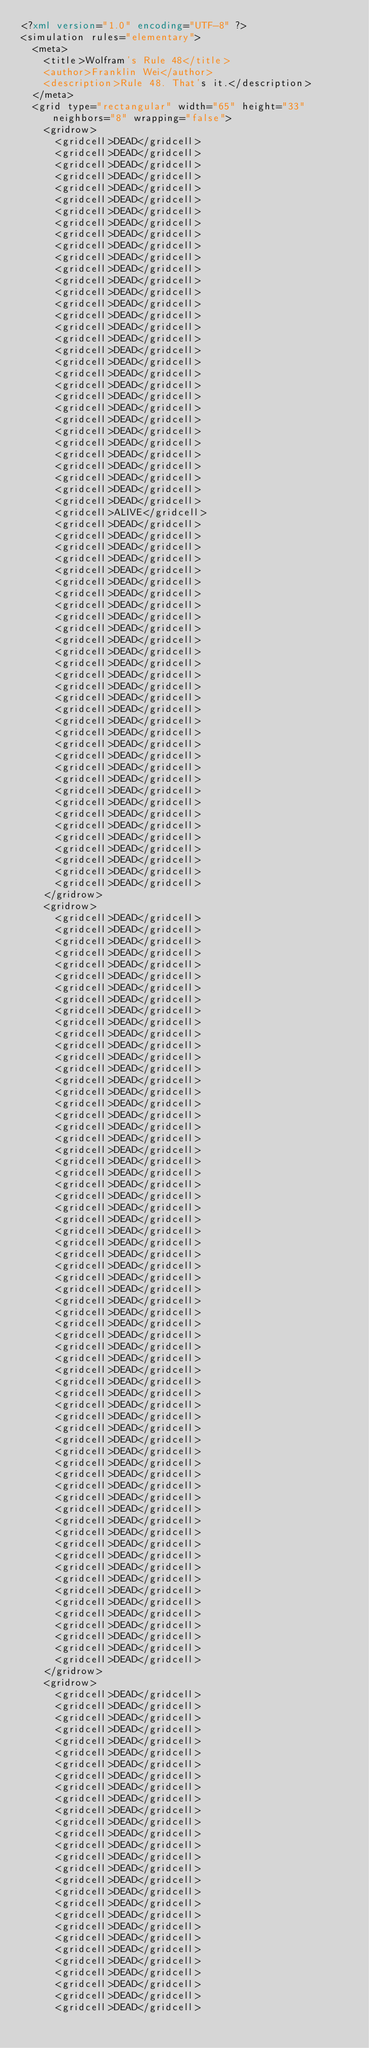<code> <loc_0><loc_0><loc_500><loc_500><_XML_><?xml version="1.0" encoding="UTF-8" ?>
<simulation rules="elementary">
  <meta>
    <title>Wolfram's Rule 48</title>
    <author>Franklin Wei</author>
    <description>Rule 48. That's it.</description>
  </meta>
  <grid type="rectangular" width="65" height="33" neighbors="8" wrapping="false">
    <gridrow>
      <gridcell>DEAD</gridcell>
      <gridcell>DEAD</gridcell>
      <gridcell>DEAD</gridcell>
      <gridcell>DEAD</gridcell>
      <gridcell>DEAD</gridcell>
      <gridcell>DEAD</gridcell>
      <gridcell>DEAD</gridcell>
      <gridcell>DEAD</gridcell>
      <gridcell>DEAD</gridcell>
      <gridcell>DEAD</gridcell>
      <gridcell>DEAD</gridcell>
      <gridcell>DEAD</gridcell>
      <gridcell>DEAD</gridcell>
      <gridcell>DEAD</gridcell>
      <gridcell>DEAD</gridcell>
      <gridcell>DEAD</gridcell>
      <gridcell>DEAD</gridcell>
      <gridcell>DEAD</gridcell>
      <gridcell>DEAD</gridcell>
      <gridcell>DEAD</gridcell>
      <gridcell>DEAD</gridcell>
      <gridcell>DEAD</gridcell>
      <gridcell>DEAD</gridcell>
      <gridcell>DEAD</gridcell>
      <gridcell>DEAD</gridcell>
      <gridcell>DEAD</gridcell>
      <gridcell>DEAD</gridcell>
      <gridcell>DEAD</gridcell>
      <gridcell>DEAD</gridcell>
      <gridcell>DEAD</gridcell>
      <gridcell>DEAD</gridcell>
      <gridcell>DEAD</gridcell>
      <gridcell>ALIVE</gridcell>
      <gridcell>DEAD</gridcell>
      <gridcell>DEAD</gridcell>
      <gridcell>DEAD</gridcell>
      <gridcell>DEAD</gridcell>
      <gridcell>DEAD</gridcell>
      <gridcell>DEAD</gridcell>
      <gridcell>DEAD</gridcell>
      <gridcell>DEAD</gridcell>
      <gridcell>DEAD</gridcell>
      <gridcell>DEAD</gridcell>
      <gridcell>DEAD</gridcell>
      <gridcell>DEAD</gridcell>
      <gridcell>DEAD</gridcell>
      <gridcell>DEAD</gridcell>
      <gridcell>DEAD</gridcell>
      <gridcell>DEAD</gridcell>
      <gridcell>DEAD</gridcell>
      <gridcell>DEAD</gridcell>
      <gridcell>DEAD</gridcell>
      <gridcell>DEAD</gridcell>
      <gridcell>DEAD</gridcell>
      <gridcell>DEAD</gridcell>
      <gridcell>DEAD</gridcell>
      <gridcell>DEAD</gridcell>
      <gridcell>DEAD</gridcell>
      <gridcell>DEAD</gridcell>
      <gridcell>DEAD</gridcell>
      <gridcell>DEAD</gridcell>
      <gridcell>DEAD</gridcell>
      <gridcell>DEAD</gridcell>
      <gridcell>DEAD</gridcell>
      <gridcell>DEAD</gridcell>
    </gridrow>
    <gridrow>
      <gridcell>DEAD</gridcell>
      <gridcell>DEAD</gridcell>
      <gridcell>DEAD</gridcell>
      <gridcell>DEAD</gridcell>
      <gridcell>DEAD</gridcell>
      <gridcell>DEAD</gridcell>
      <gridcell>DEAD</gridcell>
      <gridcell>DEAD</gridcell>
      <gridcell>DEAD</gridcell>
      <gridcell>DEAD</gridcell>
      <gridcell>DEAD</gridcell>
      <gridcell>DEAD</gridcell>
      <gridcell>DEAD</gridcell>
      <gridcell>DEAD</gridcell>
      <gridcell>DEAD</gridcell>
      <gridcell>DEAD</gridcell>
      <gridcell>DEAD</gridcell>
      <gridcell>DEAD</gridcell>
      <gridcell>DEAD</gridcell>
      <gridcell>DEAD</gridcell>
      <gridcell>DEAD</gridcell>
      <gridcell>DEAD</gridcell>
      <gridcell>DEAD</gridcell>
      <gridcell>DEAD</gridcell>
      <gridcell>DEAD</gridcell>
      <gridcell>DEAD</gridcell>
      <gridcell>DEAD</gridcell>
      <gridcell>DEAD</gridcell>
      <gridcell>DEAD</gridcell>
      <gridcell>DEAD</gridcell>
      <gridcell>DEAD</gridcell>
      <gridcell>DEAD</gridcell>
      <gridcell>DEAD</gridcell>
      <gridcell>DEAD</gridcell>
      <gridcell>DEAD</gridcell>
      <gridcell>DEAD</gridcell>
      <gridcell>DEAD</gridcell>
      <gridcell>DEAD</gridcell>
      <gridcell>DEAD</gridcell>
      <gridcell>DEAD</gridcell>
      <gridcell>DEAD</gridcell>
      <gridcell>DEAD</gridcell>
      <gridcell>DEAD</gridcell>
      <gridcell>DEAD</gridcell>
      <gridcell>DEAD</gridcell>
      <gridcell>DEAD</gridcell>
      <gridcell>DEAD</gridcell>
      <gridcell>DEAD</gridcell>
      <gridcell>DEAD</gridcell>
      <gridcell>DEAD</gridcell>
      <gridcell>DEAD</gridcell>
      <gridcell>DEAD</gridcell>
      <gridcell>DEAD</gridcell>
      <gridcell>DEAD</gridcell>
      <gridcell>DEAD</gridcell>
      <gridcell>DEAD</gridcell>
      <gridcell>DEAD</gridcell>
      <gridcell>DEAD</gridcell>
      <gridcell>DEAD</gridcell>
      <gridcell>DEAD</gridcell>
      <gridcell>DEAD</gridcell>
      <gridcell>DEAD</gridcell>
      <gridcell>DEAD</gridcell>
      <gridcell>DEAD</gridcell>
      <gridcell>DEAD</gridcell>
    </gridrow>
    <gridrow>
      <gridcell>DEAD</gridcell>
      <gridcell>DEAD</gridcell>
      <gridcell>DEAD</gridcell>
      <gridcell>DEAD</gridcell>
      <gridcell>DEAD</gridcell>
      <gridcell>DEAD</gridcell>
      <gridcell>DEAD</gridcell>
      <gridcell>DEAD</gridcell>
      <gridcell>DEAD</gridcell>
      <gridcell>DEAD</gridcell>
      <gridcell>DEAD</gridcell>
      <gridcell>DEAD</gridcell>
      <gridcell>DEAD</gridcell>
      <gridcell>DEAD</gridcell>
      <gridcell>DEAD</gridcell>
      <gridcell>DEAD</gridcell>
      <gridcell>DEAD</gridcell>
      <gridcell>DEAD</gridcell>
      <gridcell>DEAD</gridcell>
      <gridcell>DEAD</gridcell>
      <gridcell>DEAD</gridcell>
      <gridcell>DEAD</gridcell>
      <gridcell>DEAD</gridcell>
      <gridcell>DEAD</gridcell>
      <gridcell>DEAD</gridcell>
      <gridcell>DEAD</gridcell>
      <gridcell>DEAD</gridcell>
      <gridcell>DEAD</gridcell></code> 